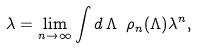<formula> <loc_0><loc_0><loc_500><loc_500>\lambda = \lim _ { n \to \infty } \int d { \, } \Lambda { \ } \rho _ { n } ( \Lambda ) \lambda ^ { n } ,</formula> 